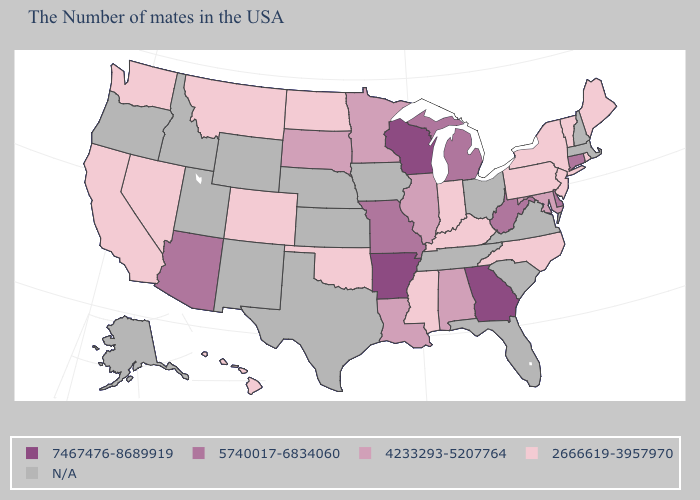Does Michigan have the lowest value in the USA?
Answer briefly. No. Does Michigan have the lowest value in the USA?
Keep it brief. No. How many symbols are there in the legend?
Concise answer only. 5. What is the value of New Mexico?
Give a very brief answer. N/A. What is the value of Georgia?
Be succinct. 7467476-8689919. Does Delaware have the highest value in the USA?
Concise answer only. No. Is the legend a continuous bar?
Answer briefly. No. Among the states that border Alabama , does Mississippi have the highest value?
Keep it brief. No. Does Wisconsin have the highest value in the MidWest?
Be succinct. Yes. What is the value of Maine?
Short answer required. 2666619-3957970. Name the states that have a value in the range 5740017-6834060?
Answer briefly. Connecticut, Delaware, West Virginia, Michigan, Missouri, Arizona. What is the lowest value in the USA?
Give a very brief answer. 2666619-3957970. What is the highest value in states that border Alabama?
Quick response, please. 7467476-8689919. What is the lowest value in the Northeast?
Quick response, please. 2666619-3957970. Which states have the highest value in the USA?
Concise answer only. Georgia, Wisconsin, Arkansas. 